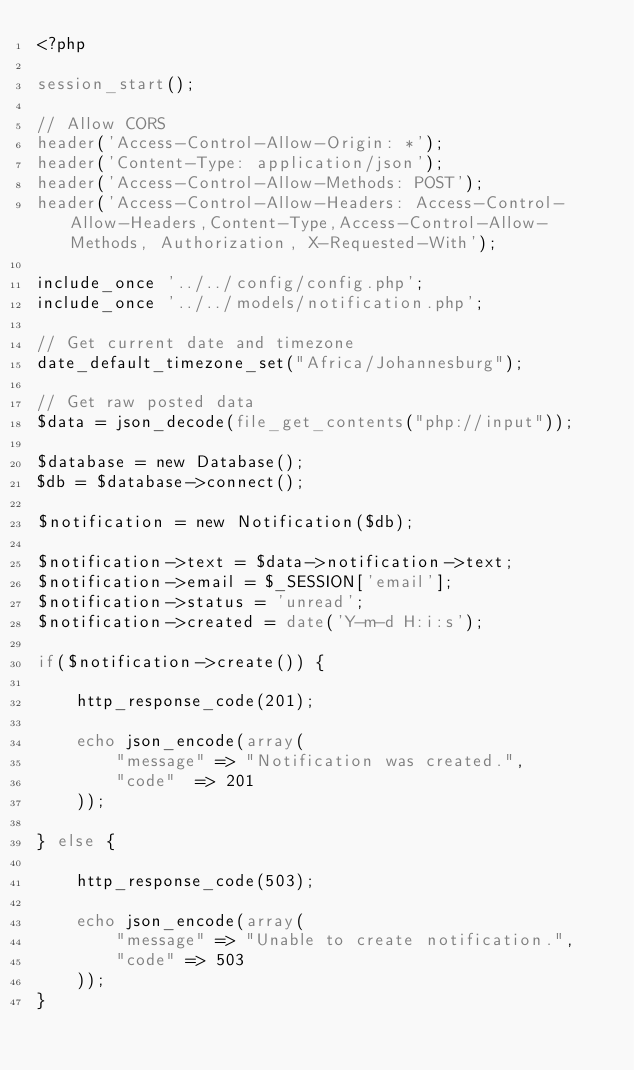Convert code to text. <code><loc_0><loc_0><loc_500><loc_500><_PHP_><?php 

session_start();

// Allow CORS
header('Access-Control-Allow-Origin: *');
header('Content-Type: application/json');
header('Access-Control-Allow-Methods: POST');
header('Access-Control-Allow-Headers: Access-Control-Allow-Headers,Content-Type,Access-Control-Allow-Methods, Authorization, X-Requested-With');
  
include_once '../../config/config.php';
include_once '../../models/notification.php';

// Get current date and timezone
date_default_timezone_set("Africa/Johannesburg");

// Get raw posted data
$data = json_decode(file_get_contents("php://input"));

$database = new Database();
$db = $database->connect();

$notification = new Notification($db);

$notification->text = $data->notification->text;
$notification->email = $_SESSION['email'];
$notification->status = 'unread';
$notification->created = date('Y-m-d H:i:s');

if($notification->create()) {

    http_response_code(201);

    echo json_encode(array(
        "message" => "Notification was created.",
        "code"  => 201
    ));

} else {

    http_response_code(503);

    echo json_encode(array(
        "message" => "Unable to create notification.",
        "code" => 503
    ));
}</code> 